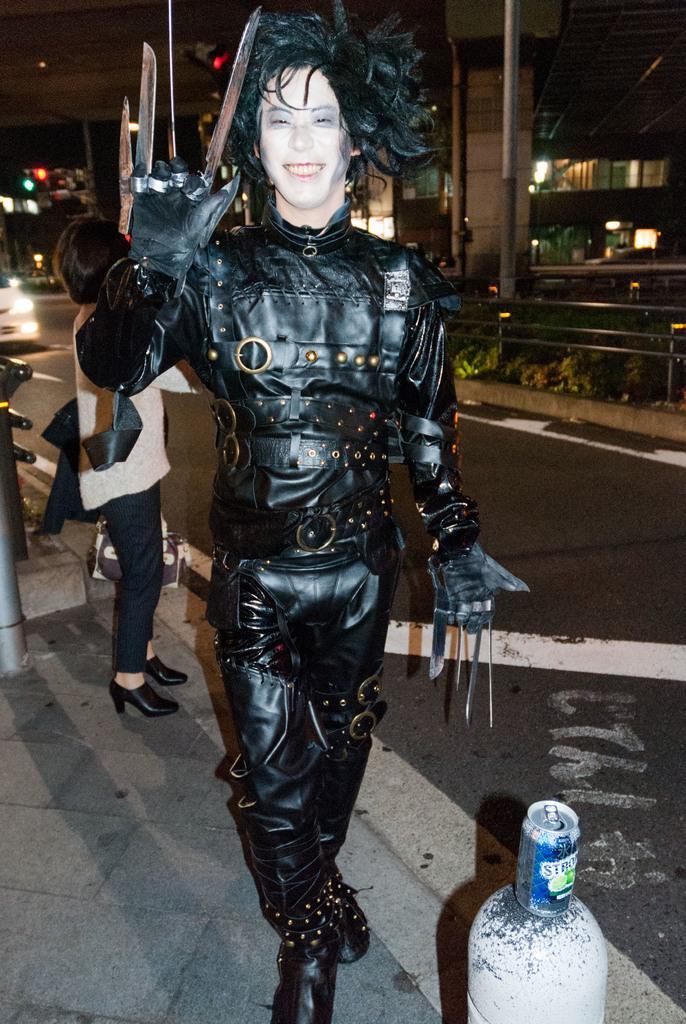In one or two sentences, can you explain what this image depicts? In the center of the image a man is standing and wearing costume. In the background of the image we can see person, building, wall, poles, fencing, plants, traffic lights. At the bottom of the image we can see a pole, on pole tin is there. In the background of the image there is a road. At the top of the image we can see the sky. On the left side of the image we can see a car. 